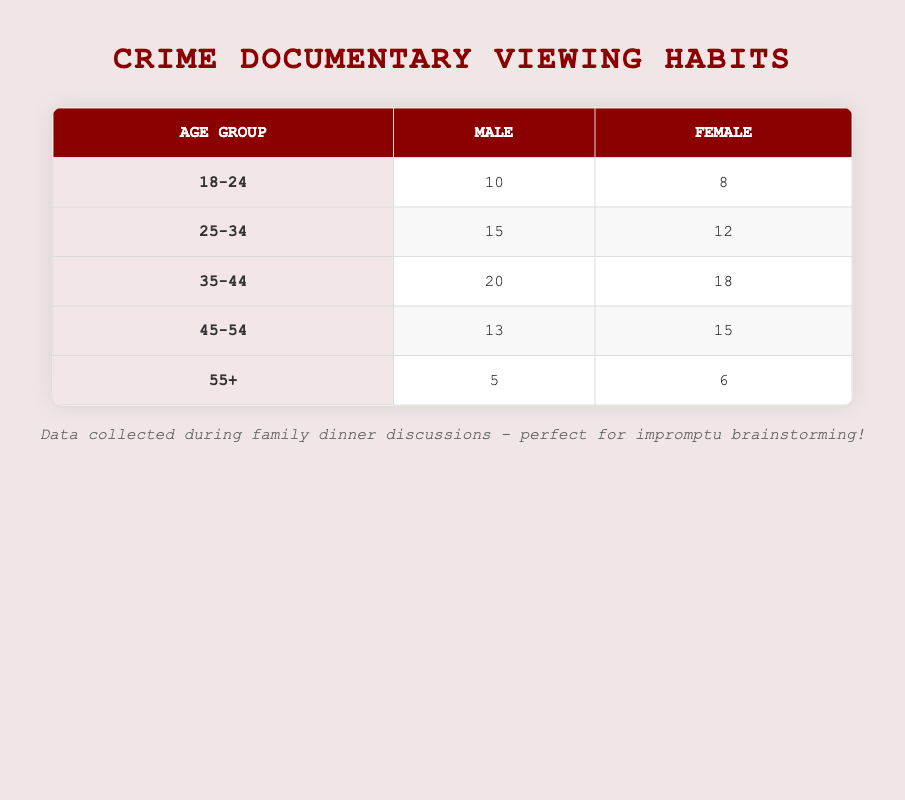What is the total number of documentaries watched by males aged 25-34? The table shows that males in the age group of 25-34 watched 15 documentaries.
Answer: 15 What is the total number of documentaries watched by females across all age groups? We need to sum the number of documentaries watched by females in each age group: 8 (18-24) + 12 (25-34) + 18 (35-44) + 15 (45-54) + 6 (55+) = 59.
Answer: 59 Which gender watched more documentaries in the age group 35-44? According to the table, males watched 20 documentaries while females watched 18 documentaries. Since 20 is greater than 18, males watched more.
Answer: Males What is the average number of documentaries watched by males in all age groups? To calculate the average, sum the documentaries watched by males: 10 (18-24) + 15 (25-34) + 20 (35-44) + 13 (45-54) + 5 (55+) = 73. There are 5 age groups, so the average is 73/5 = 14.6.
Answer: 14.6 Is it true that the number of documentaries watched by females aged 55 and above is higher than those watched by males in the same age group? In the 55+ age group, females watched 6 documentaries, while males watched 5 documentaries. Since 6 is greater than 5, the statement is true.
Answer: Yes What is the difference in the number of documentaries watched by males and females in the age group 45-54? Males watched 13 documentaries while females watched 15. The difference is 15 - 13 = 2.
Answer: 2 What percentage of the total documentaries watched by the 18-24 age group is accounted for by females? The total number of documentaries watched by the 18-24 age group is 10 (males) + 8 (females) = 18. Females watched 8 documentaries, so the percentage is (8/18) * 100 ≈ 44.44%.
Answer: 44.44% Which age group watched the least number of documentaries? By examining the table, the age group 55+ has the smallest total of 5 (males) + 6 (females) = 11 documentaries. Thus, they watched the least.
Answer: 55+ Did more males or females watch documentaries in the age group 25-34? The table indicates that males watched 15 documentaries while females watched 12 documentaries. Since 15 is greater than 12, more males watched documentaries.
Answer: Males 